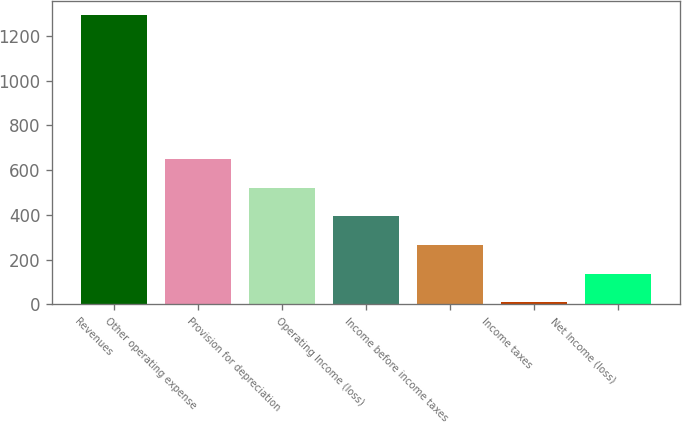<chart> <loc_0><loc_0><loc_500><loc_500><bar_chart><fcel>Revenues<fcel>Other operating expense<fcel>Provision for depreciation<fcel>Operating Income (loss)<fcel>Income before income taxes<fcel>Income taxes<fcel>Net Income (loss)<nl><fcel>1292<fcel>651<fcel>522.8<fcel>394.6<fcel>266.4<fcel>10<fcel>138.2<nl></chart> 